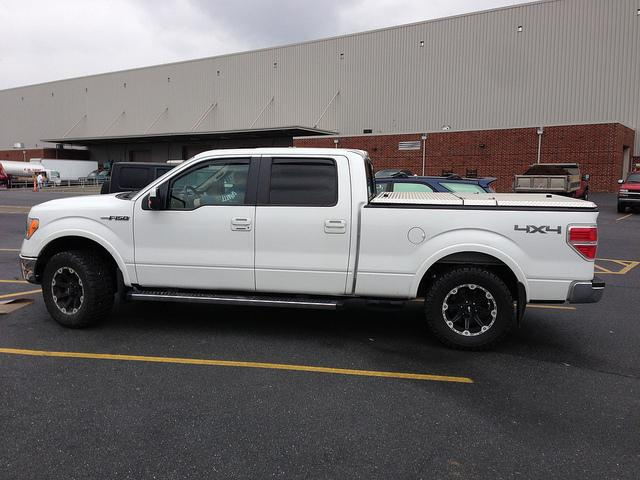What is the answer to the equation on the side of the truck? sixteen 